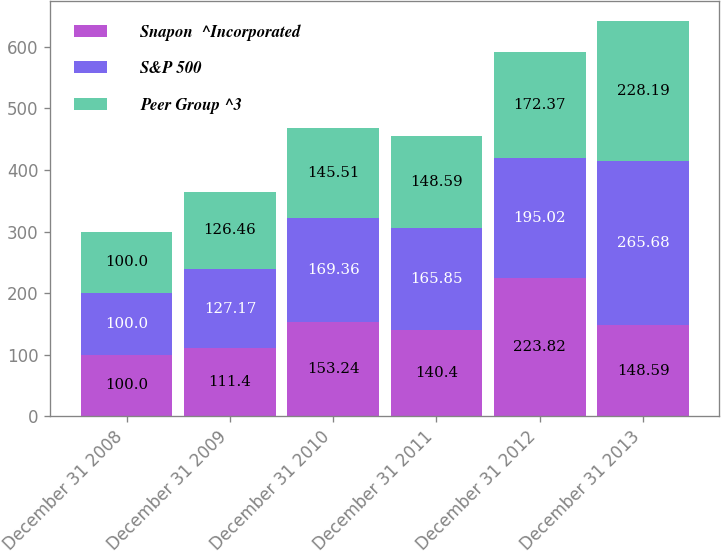Convert chart to OTSL. <chart><loc_0><loc_0><loc_500><loc_500><stacked_bar_chart><ecel><fcel>December 31 2008<fcel>December 31 2009<fcel>December 31 2010<fcel>December 31 2011<fcel>December 31 2012<fcel>December 31 2013<nl><fcel>Snapon  ^Incorporated<fcel>100<fcel>111.4<fcel>153.24<fcel>140.4<fcel>223.82<fcel>148.59<nl><fcel>S&P 500<fcel>100<fcel>127.17<fcel>169.36<fcel>165.85<fcel>195.02<fcel>265.68<nl><fcel>Peer Group ^3<fcel>100<fcel>126.46<fcel>145.51<fcel>148.59<fcel>172.37<fcel>228.19<nl></chart> 